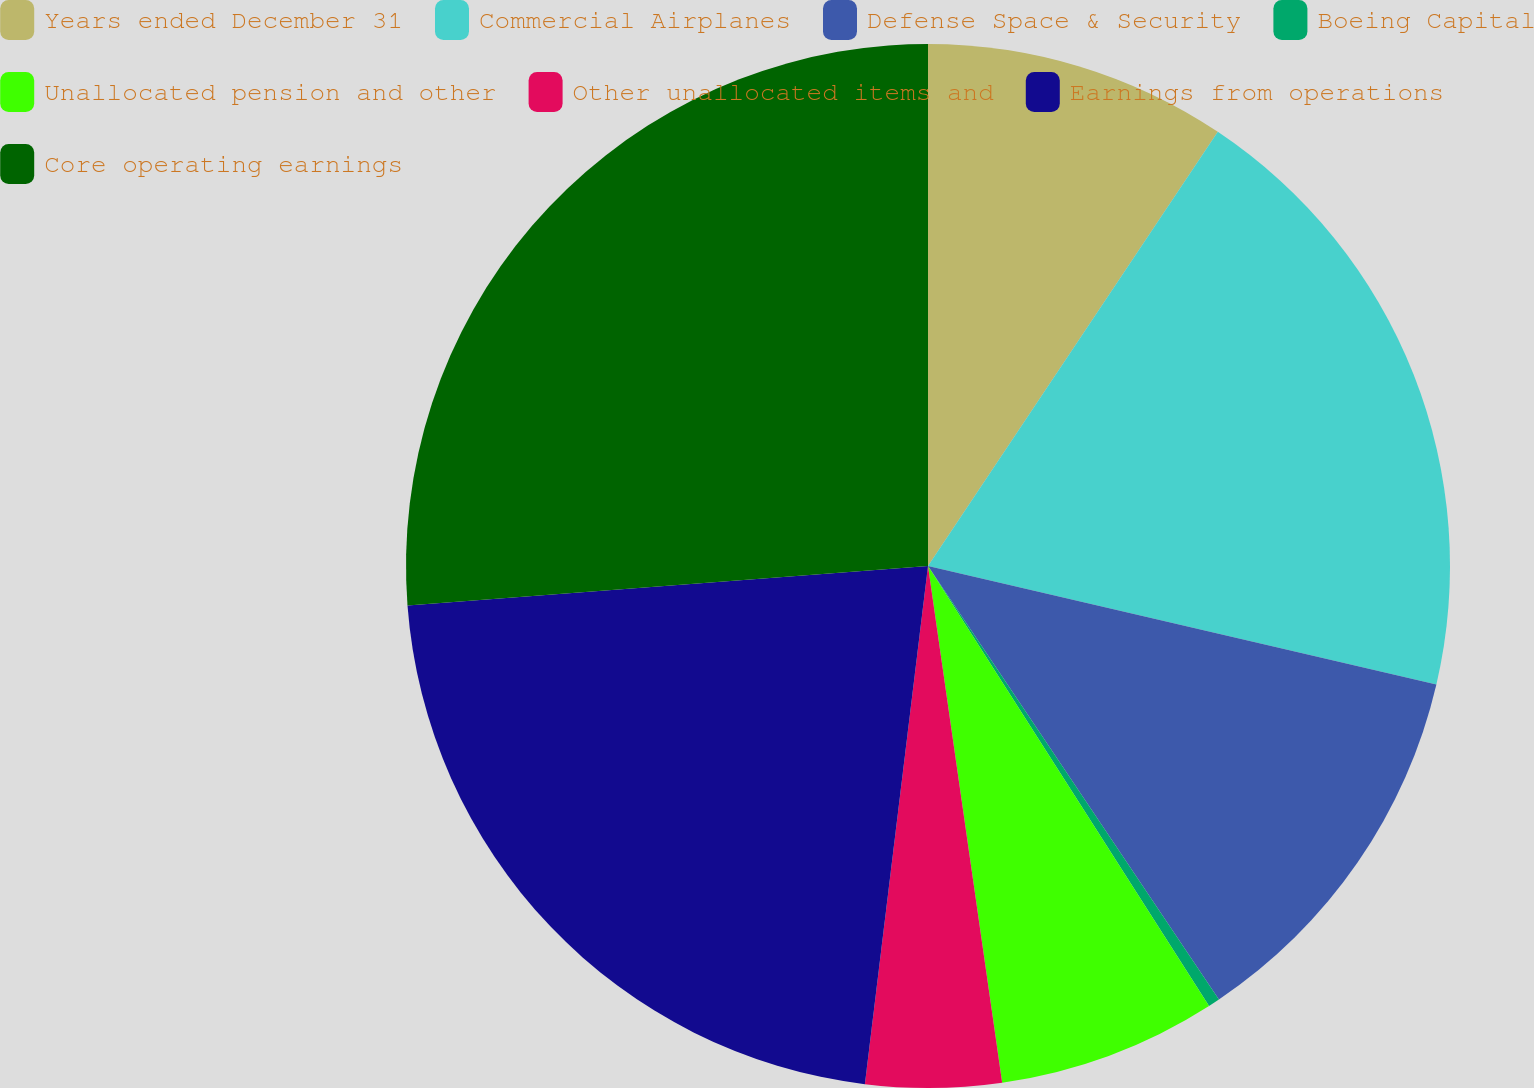Convert chart to OTSL. <chart><loc_0><loc_0><loc_500><loc_500><pie_chart><fcel>Years ended December 31<fcel>Commercial Airplanes<fcel>Defense Space & Security<fcel>Boeing Capital<fcel>Unallocated pension and other<fcel>Other unallocated items and<fcel>Earnings from operations<fcel>Core operating earnings<nl><fcel>9.37%<fcel>19.28%<fcel>11.95%<fcel>0.36%<fcel>6.78%<fcel>4.2%<fcel>21.87%<fcel>26.21%<nl></chart> 